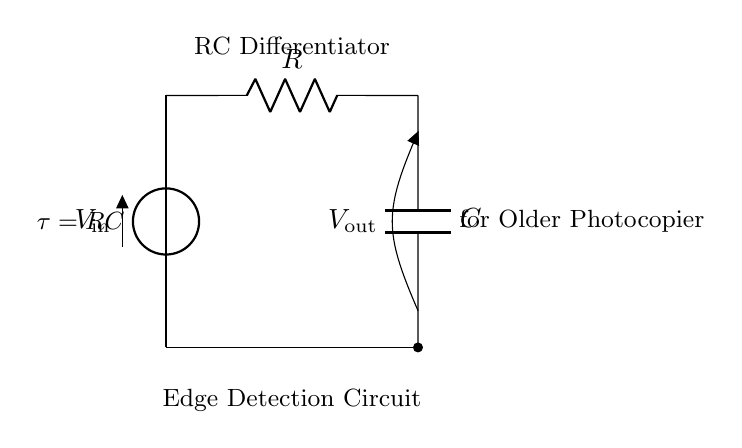What type of circuit is this? This circuit is labeled as an "RC Differentiator," which indicates that it is designed to differentiate voltage signals using resistors and capacitors.
Answer: RC Differentiator What is the output of the circuit? The output is indicated as "V out," which signifies the voltage across the capacitor in the differentiator configuration once a transient input signal is applied.
Answer: V out What does the symbol "C" represent? The symbol "C" in the circuit represents a capacitor, which stores electrical energy in an electric field and is a key component in the differentiator circuit.
Answer: Capacitor What is the time constant formula presented? The label within the circuit indicates that the time constant is given by the formula "tau equals R times C," which characterizes the response time of the circuit to voltage changes.
Answer: tau equals R C How does this circuit perform edge detection? This circuit responds to changes in the input voltage (like edges in a signal) by producing a spike in the output voltage, effectively detecting the rise or fall of the signal, which is useful for edge detection.
Answer: Produces voltage spike What happens to the output when the input voltage changes rapidly? When the input voltage changes rapidly, the capacitor responds quickly to the change, leading to a sharp output change, reflecting the rate of voltage change in the input, indicative of edge detection.
Answer: Sharp output change 